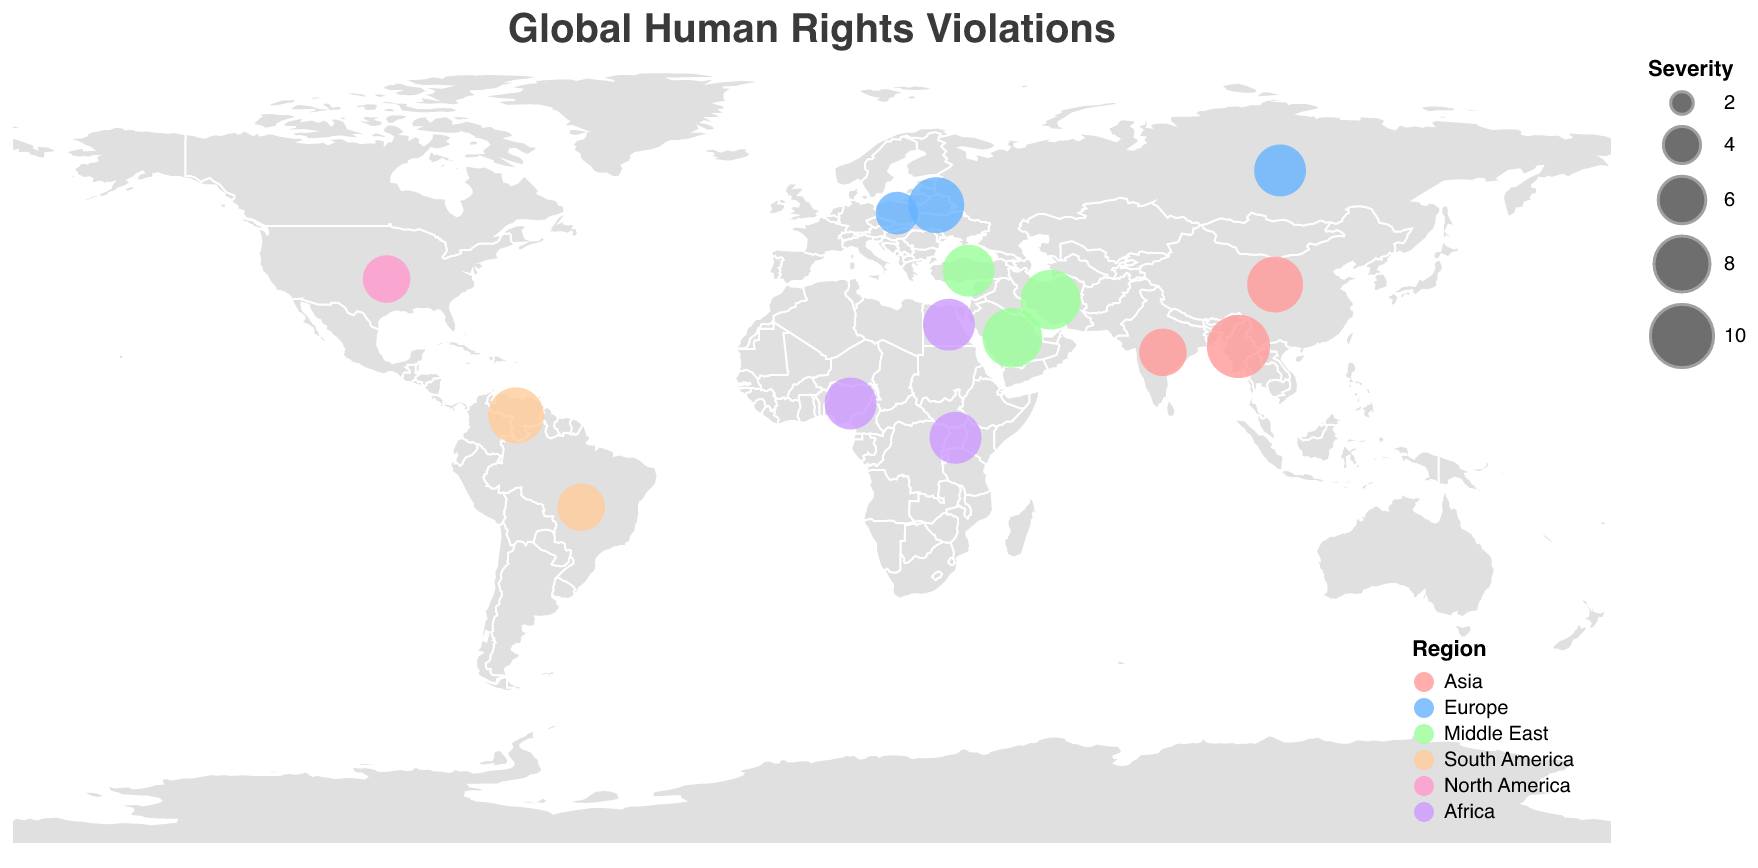How many regions are represented in the map? The legend shows the colors assigned to each region. By counting the different colors in the legend, we see there are six regions: Asia, Europe, Middle East, South America, North America, and Africa.
Answer: 6 Which country has the highest severity of human rights violations? The size of the circles represents the severity of violations. The largest circle corresponds to Myanmar with a severity of 10.
Answer: Myanmar What type of human rights violation is observed in Iran, and what's its severity? Hovering over Iran's data point reveals the type of violation and its severity. The tooltip shows "Religious Freedom" with a severity of 9.
Answer: Religious Freedom, 9 How does the severity of human rights violations in Venezuela compare to Brazil? By comparing the sizes of circles, Venezuela's severity in Political Prisoners is 8, while Brazil's severity in Indigenous Rights is 6. Venezuela has a higher severity.
Answer: Venezuela is higher How many countries in the Middle East are listed, and what types of violations do they report? The tooltip data shows violations in Saudi Arabia (Women's Rights), Iran (Religious Freedom), and Turkey (Academic Freedom). There are three countries with specified types of violations.
Answer: 3, Women's Rights, Religious Freedom, Academic Freedom What's the average severity of human rights violations in Asia? The Asian countries listed are China (8), Myanmar (10), and India (6). The average is calculated as (8 + 10 + 6)/3 = 8.
Answer: 8 Which region has the most severe violation in terms of severity, and which country is it? By examining the largest circle in the regions, Myanmar in Asia shows the highest severity of 10 for Ethnic Cleansing.
Answer: Asia, Myanmar What is the total number of countries with a severity level above 7? Countries with severity levels above 7 are China (8), Saudi Arabia (9), Venezuela (8), Myanmar (10), Iran (9), Belarus (8), and Egypt (7). Counting these gives a total of 7 countries.
Answer: 7 Which two regions have the same severity score of 7 but for different violation types? By checking the tooltips, Nigeria (Africa) with LGBTQ+ Rights and Russia (Europe) with Political Persecution both have a severity of 7. Another set is Turkey (Middle East) with Academic Freedom and Egypt (Africa) with Arbitrary Detention.
Answer: Africa & Europe (Nigeria and Russia), Middle East & Africa (Turkey and Egypt) What color represents the violations in Europe? The legend shows the color for each region. Europe's violations are represented by a shade of blue.
Answer: Blue 